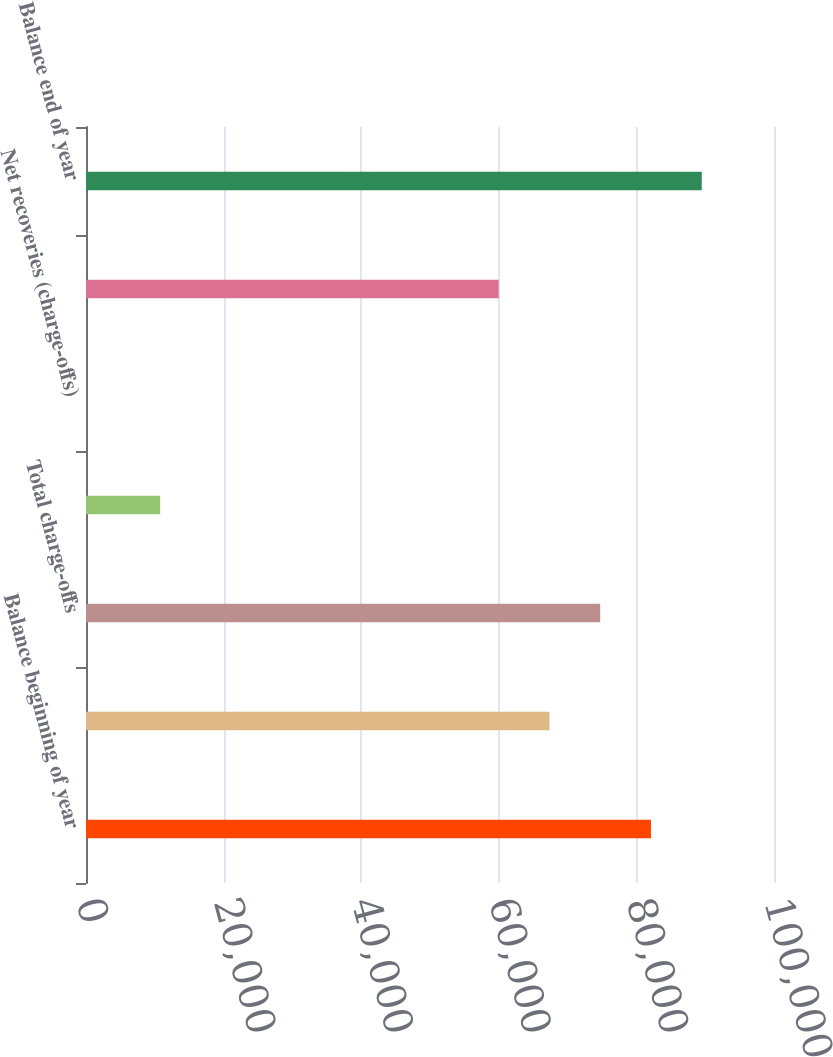Convert chart to OTSL. <chart><loc_0><loc_0><loc_500><loc_500><bar_chart><fcel>Balance beginning of year<fcel>Commercial<fcel>Total charge-offs<fcel>Total recoveries<fcel>Net recoveries (charge-offs)<fcel>Provision for loan losses<fcel>Balance end of year<nl><fcel>82120.7<fcel>67361.3<fcel>74741<fcel>10778<fcel>3.3<fcel>59981.7<fcel>89500.4<nl></chart> 